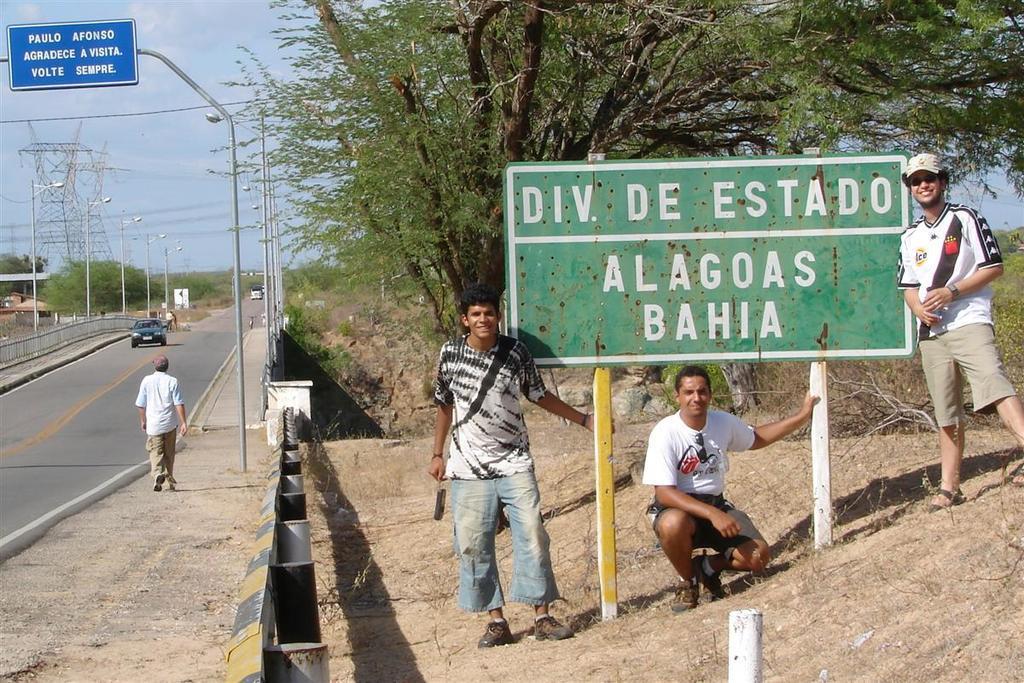Can you describe this image briefly? This is a sign board in the right side, few men are standing and smiling behind them there are trees. In the left side a man is walking on the footpath, this is the road. 